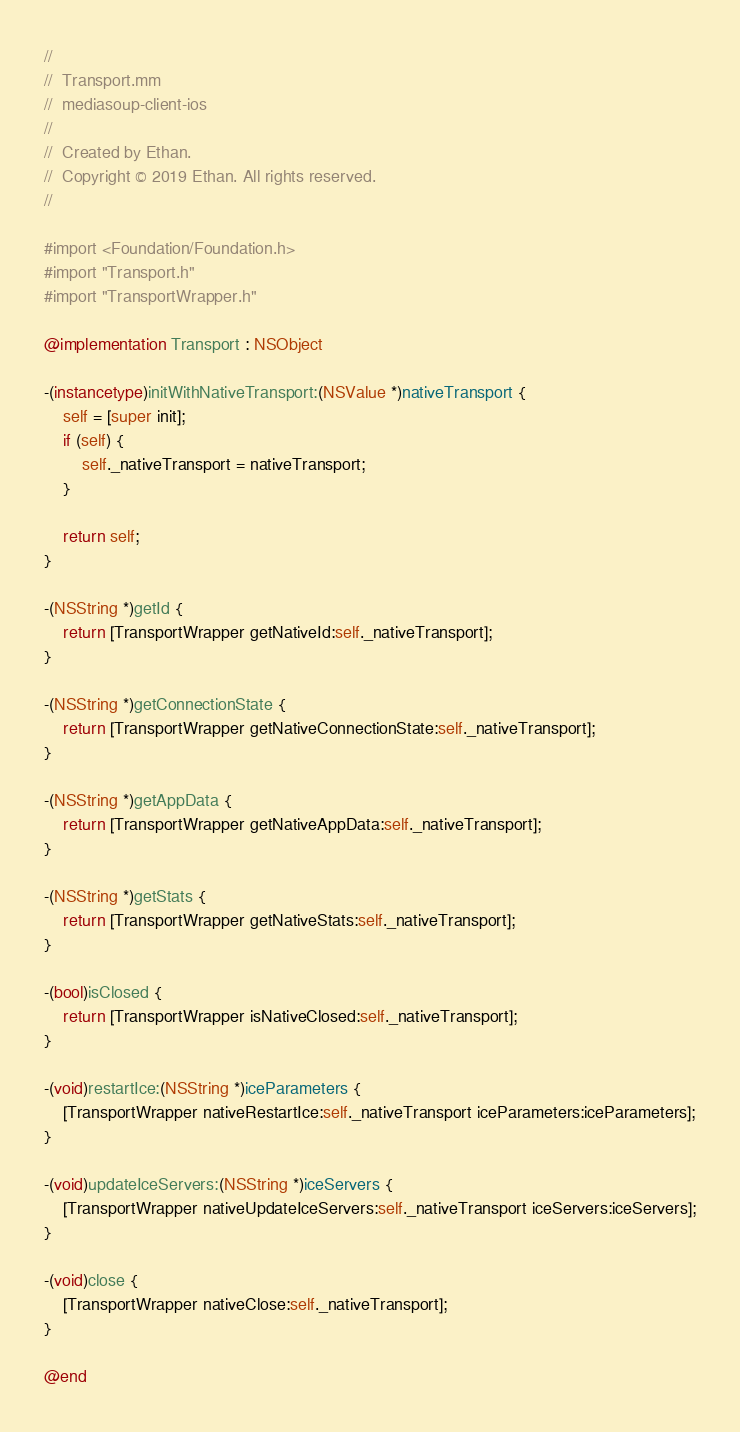<code> <loc_0><loc_0><loc_500><loc_500><_ObjectiveC_>//
//  Transport.mm
//  mediasoup-client-ios
//
//  Created by Ethan.
//  Copyright © 2019 Ethan. All rights reserved.
//

#import <Foundation/Foundation.h>
#import "Transport.h"
#import "TransportWrapper.h"

@implementation Transport : NSObject

-(instancetype)initWithNativeTransport:(NSValue *)nativeTransport {
    self = [super init];
    if (self) {
        self._nativeTransport = nativeTransport;
    }
    
    return self;
}

-(NSString *)getId {
    return [TransportWrapper getNativeId:self._nativeTransport];
}

-(NSString *)getConnectionState {
    return [TransportWrapper getNativeConnectionState:self._nativeTransport];
}

-(NSString *)getAppData {
    return [TransportWrapper getNativeAppData:self._nativeTransport];
}

-(NSString *)getStats {
    return [TransportWrapper getNativeStats:self._nativeTransport];
}

-(bool)isClosed {
    return [TransportWrapper isNativeClosed:self._nativeTransport];
}

-(void)restartIce:(NSString *)iceParameters {
    [TransportWrapper nativeRestartIce:self._nativeTransport iceParameters:iceParameters];
}

-(void)updateIceServers:(NSString *)iceServers {
    [TransportWrapper nativeUpdateIceServers:self._nativeTransport iceServers:iceServers];
}

-(void)close {
    [TransportWrapper nativeClose:self._nativeTransport];
}

@end
</code> 